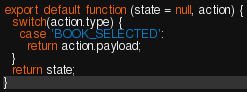Convert code to text. <code><loc_0><loc_0><loc_500><loc_500><_JavaScript_>export default function (state = null, action) {
  switch(action.type) {
    case 'BOOK_SELECTED':
      return action.payload;
  }
  return state;
}</code> 